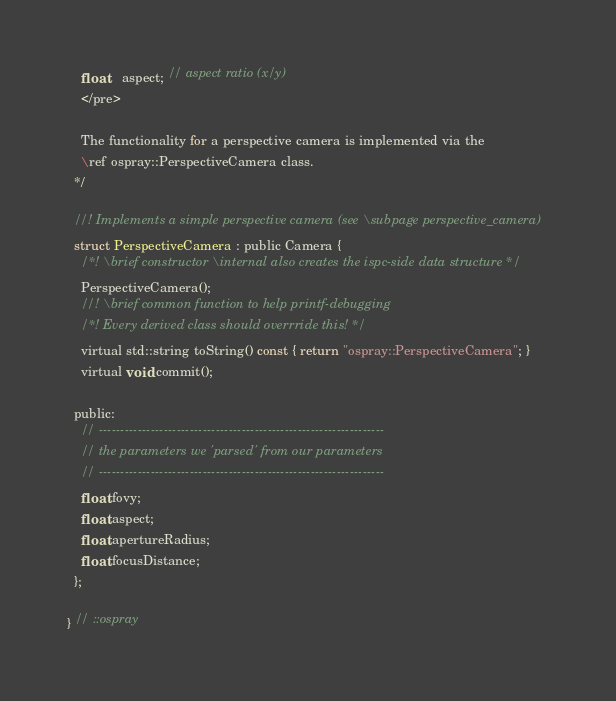Convert code to text. <code><loc_0><loc_0><loc_500><loc_500><_C_>    float    aspect; // aspect ratio (x/y)
    </pre>

    The functionality for a perspective camera is implemented via the
    \ref ospray::PerspectiveCamera class.
  */

  //! Implements a simple perspective camera (see \subpage perspective_camera)
  struct PerspectiveCamera : public Camera {
    /*! \brief constructor \internal also creates the ispc-side data structure */
    PerspectiveCamera();
    //! \brief common function to help printf-debugging 
    /*! Every derived class should overrride this! */
    virtual std::string toString() const { return "ospray::PerspectiveCamera"; }
    virtual void commit();
    
  public:
    // ------------------------------------------------------------------
    // the parameters we 'parsed' from our parameters
    // ------------------------------------------------------------------
    float fovy;
    float aspect;
    float apertureRadius;
    float focusDistance;
  };

} // ::ospray
</code> 